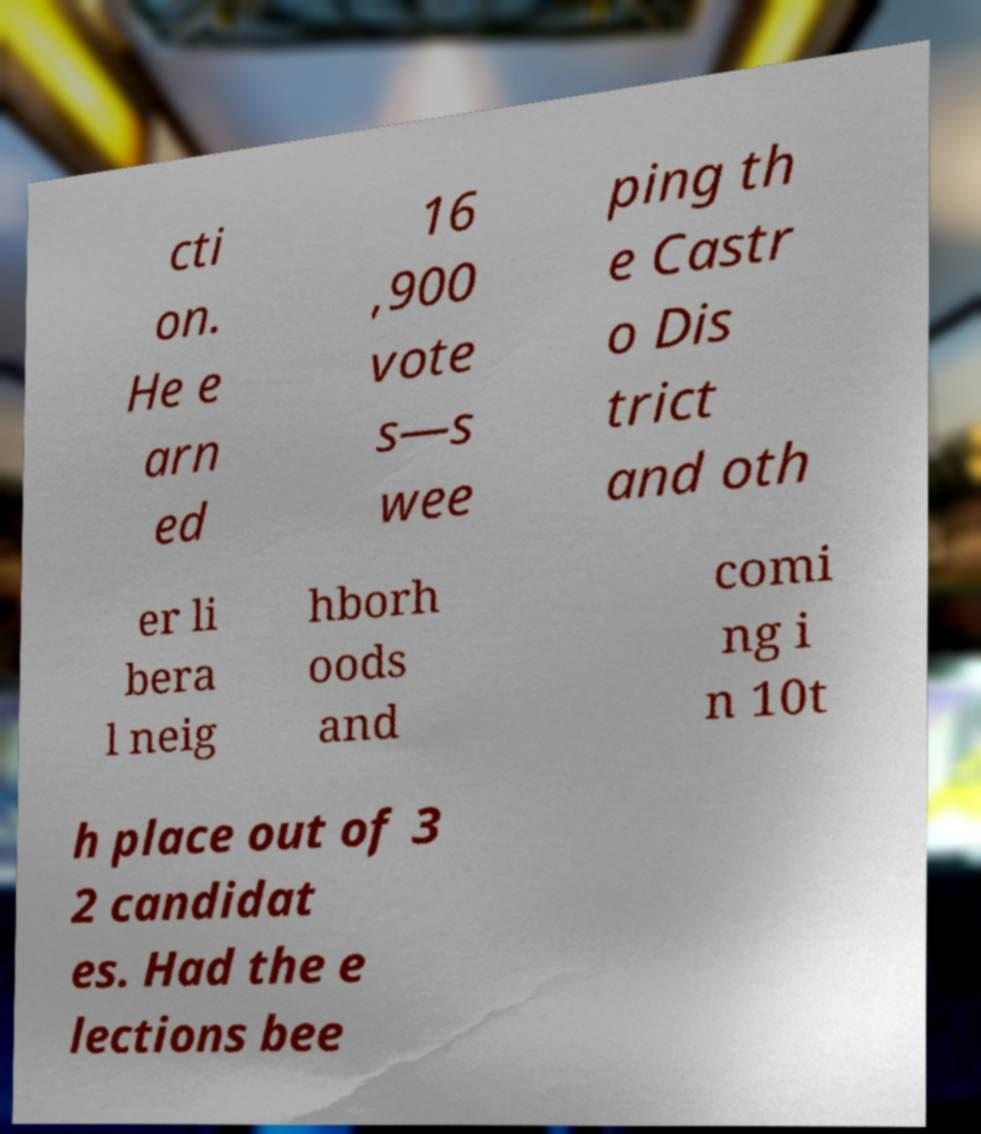There's text embedded in this image that I need extracted. Can you transcribe it verbatim? cti on. He e arn ed 16 ,900 vote s—s wee ping th e Castr o Dis trict and oth er li bera l neig hborh oods and comi ng i n 10t h place out of 3 2 candidat es. Had the e lections bee 